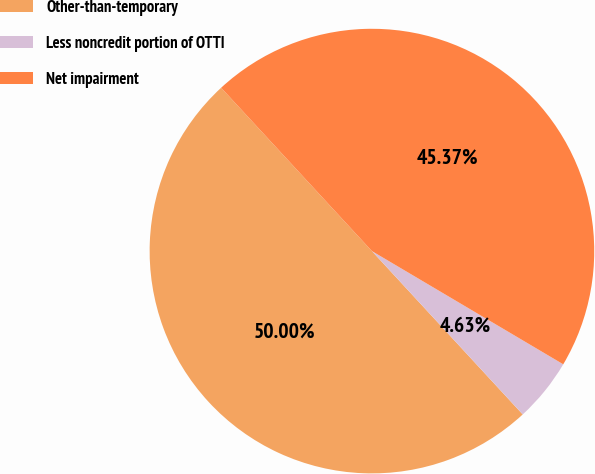Convert chart to OTSL. <chart><loc_0><loc_0><loc_500><loc_500><pie_chart><fcel>Other-than-temporary<fcel>Less noncredit portion of OTTI<fcel>Net impairment<nl><fcel>50.0%<fcel>4.63%<fcel>45.37%<nl></chart> 